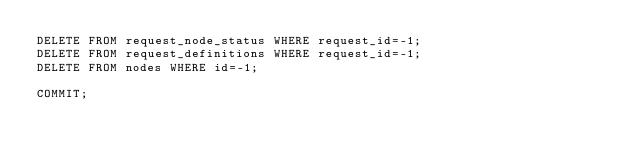Convert code to text. <code><loc_0><loc_0><loc_500><loc_500><_SQL_>DELETE FROM request_node_status WHERE request_id=-1;
DELETE FROM request_definitions WHERE request_id=-1;
DELETE FROM nodes WHERE id=-1;

COMMIT;
</code> 